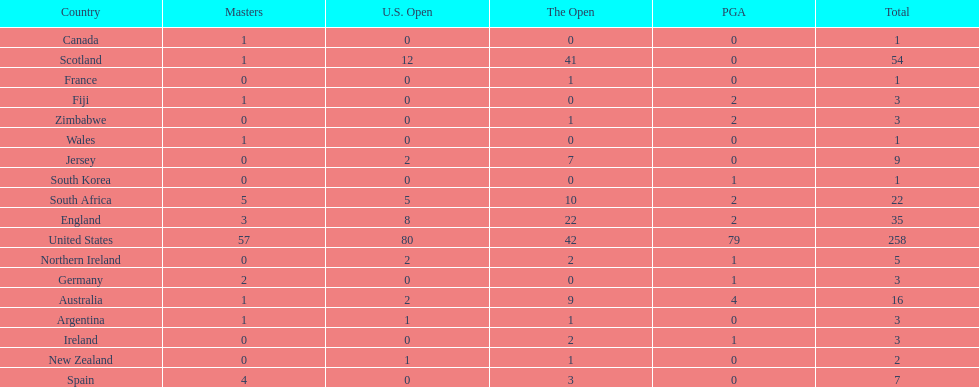How many total championships does spain have? 7. 